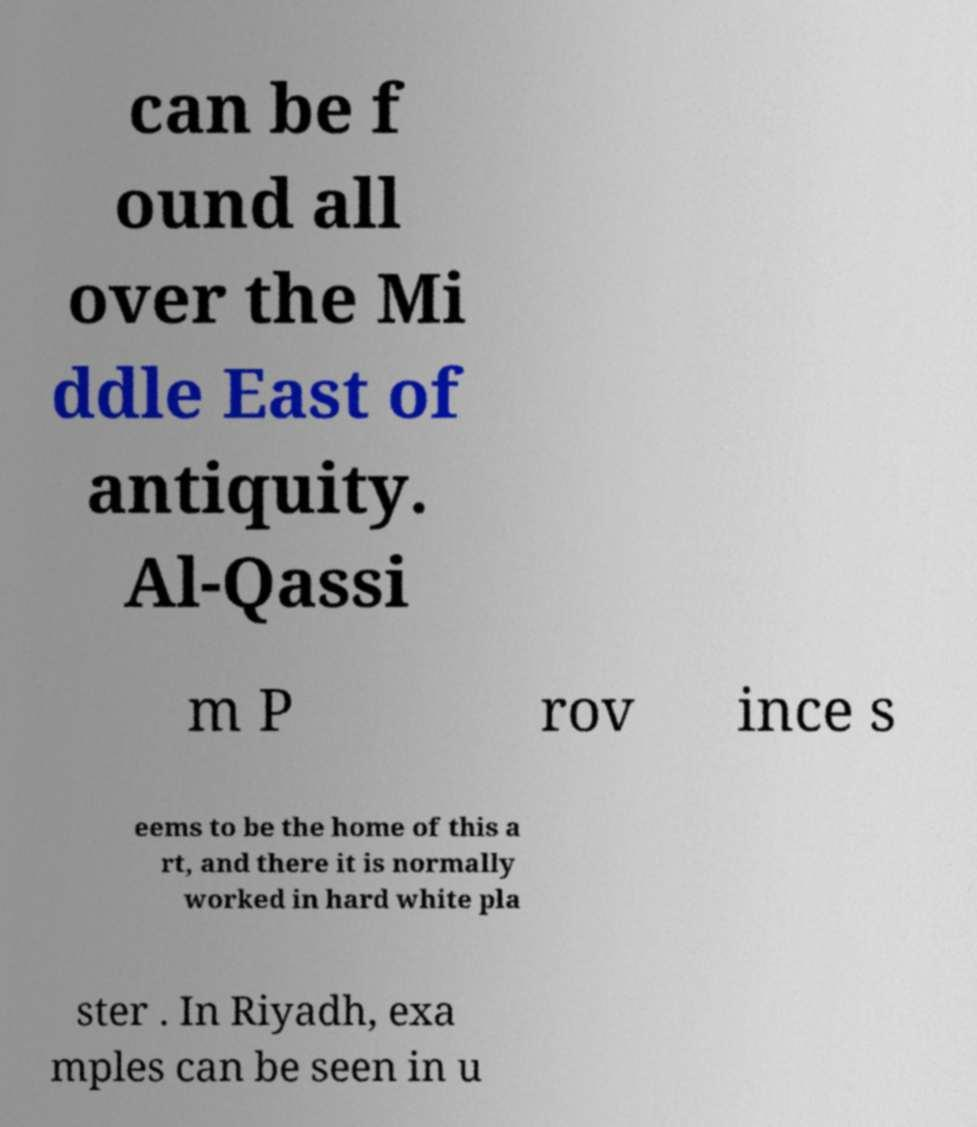Can you accurately transcribe the text from the provided image for me? can be f ound all over the Mi ddle East of antiquity. Al-Qassi m P rov ince s eems to be the home of this a rt, and there it is normally worked in hard white pla ster . In Riyadh, exa mples can be seen in u 